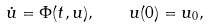<formula> <loc_0><loc_0><loc_500><loc_500>\dot { u } = \Phi ( t , u ) , \quad u ( 0 ) = u _ { 0 } ,</formula> 